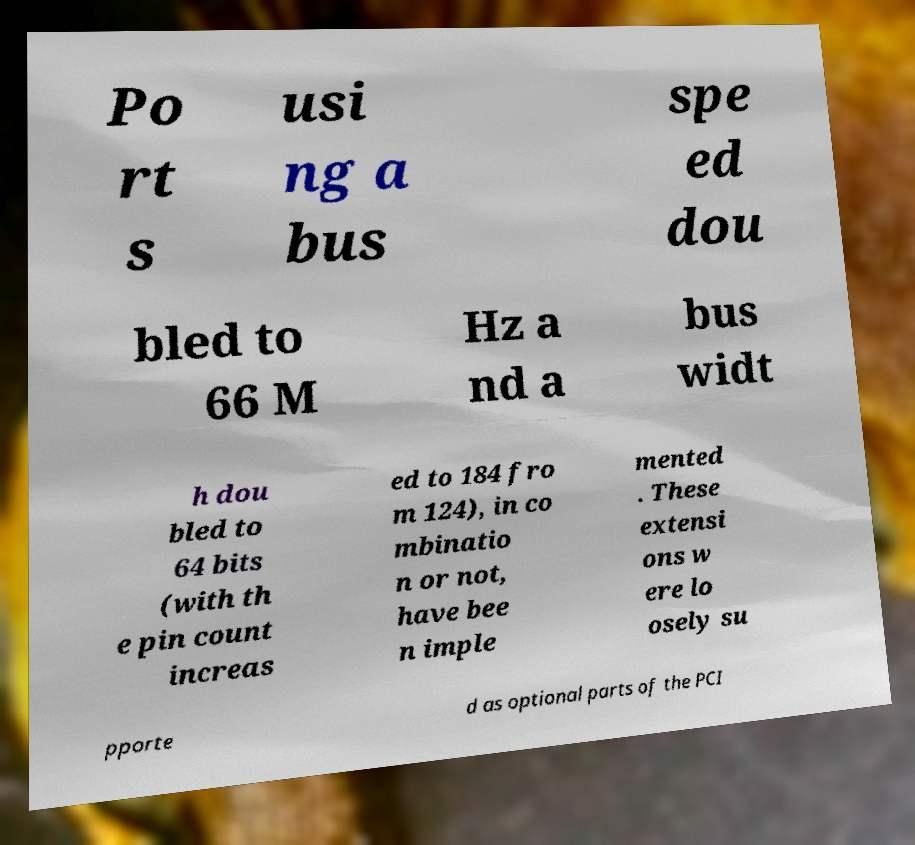Could you assist in decoding the text presented in this image and type it out clearly? Po rt s usi ng a bus spe ed dou bled to 66 M Hz a nd a bus widt h dou bled to 64 bits (with th e pin count increas ed to 184 fro m 124), in co mbinatio n or not, have bee n imple mented . These extensi ons w ere lo osely su pporte d as optional parts of the PCI 